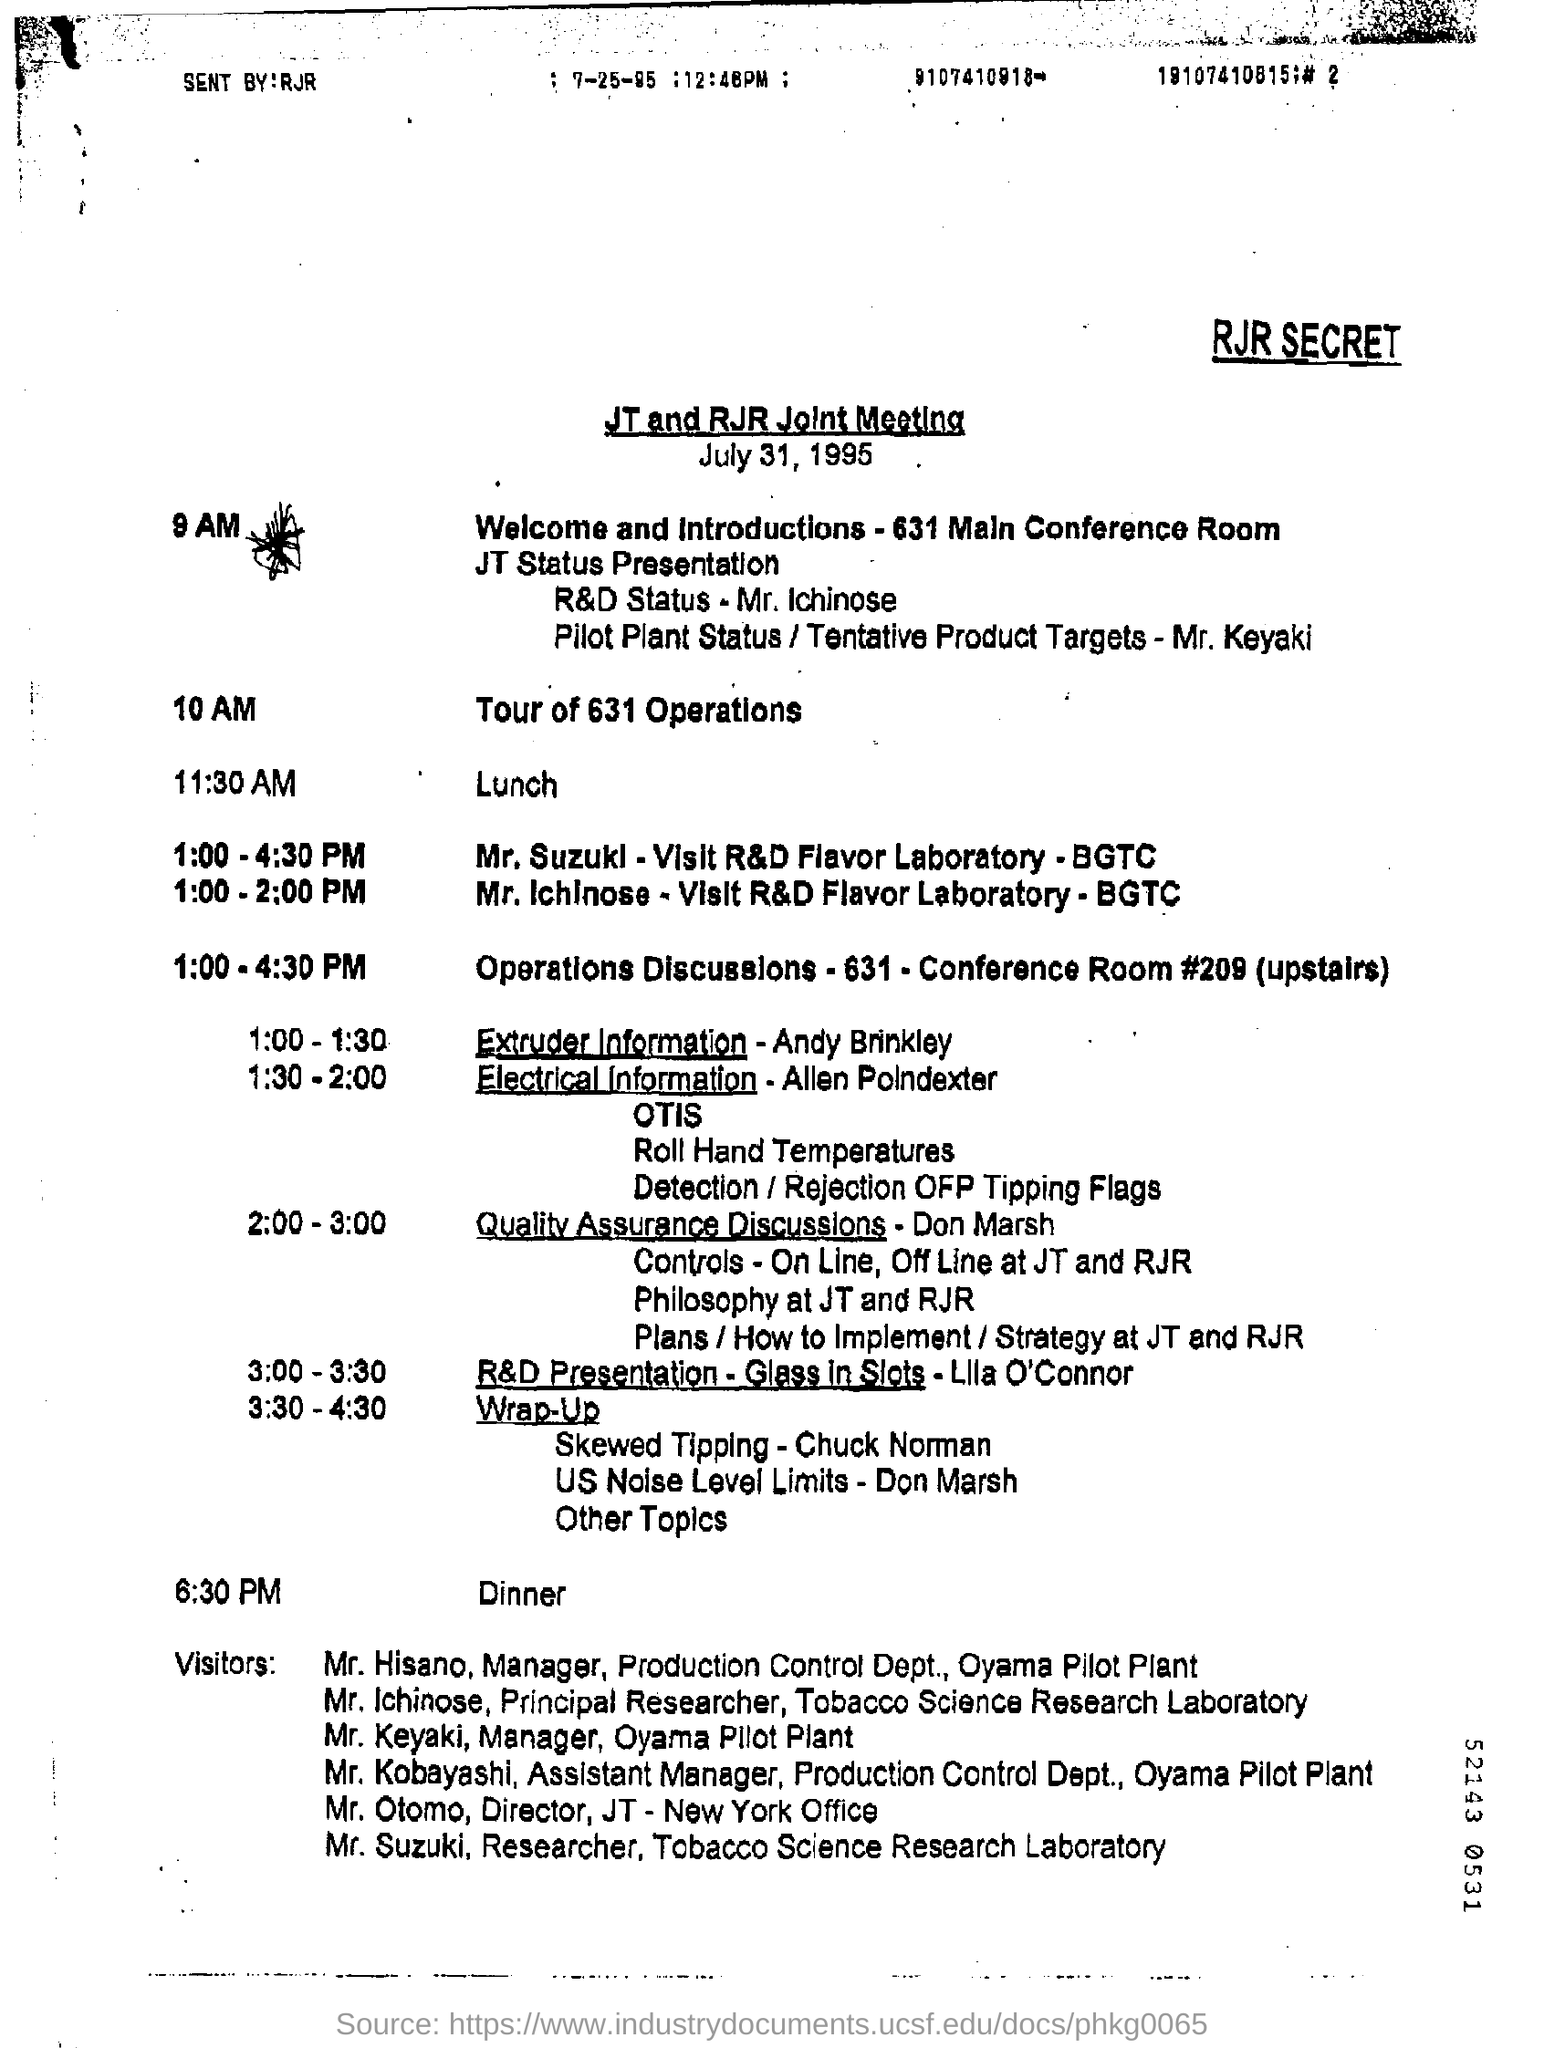Point out several critical features in this image. The date is July 31, 1995. The title of this document is 'What is the Title for the Document? JT and RJR Joint Meeting..'. The lunch is scheduled for 11:30 AM. 